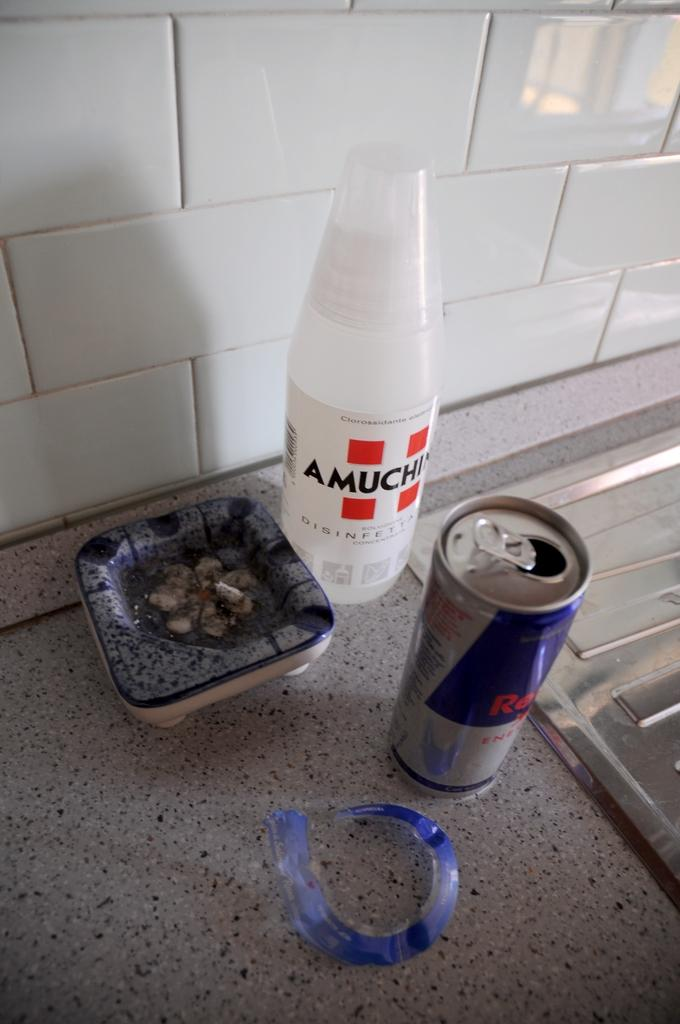<image>
Provide a brief description of the given image. White Amuchin bottle next to an open Red Bull. 